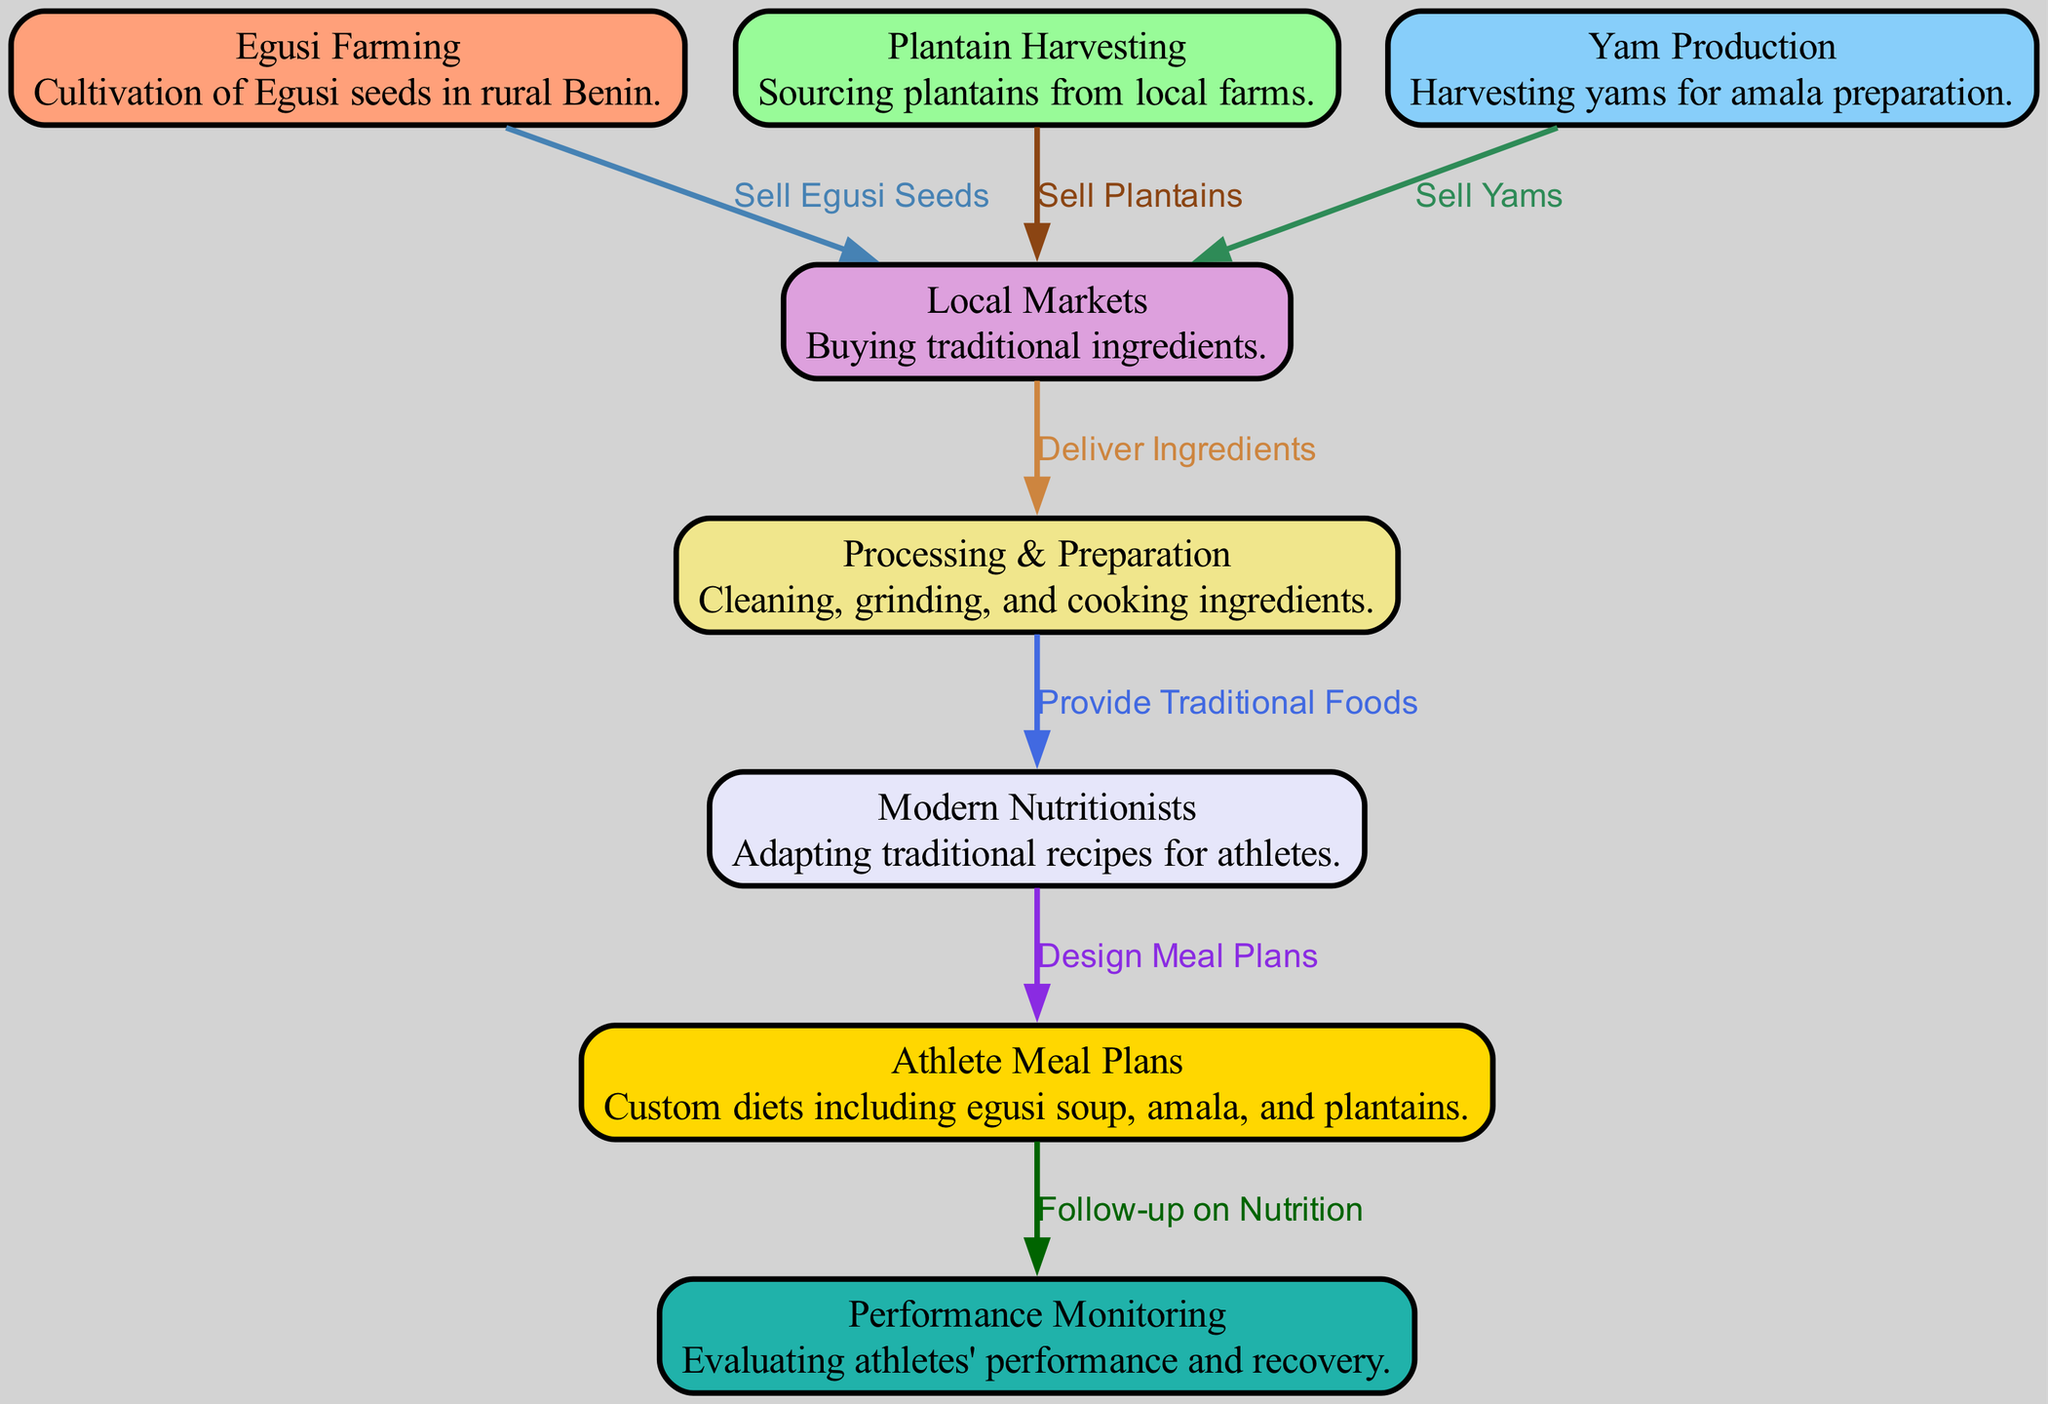What is the first node in the diagram? The first node is "Egusi Farming," which represents the cultivation of Egusi seeds. This can be determined by looking at the order of the nodes listed in the diagram.
Answer: Egusi Farming How many nodes are there in the food chain? By counting the individual nodes listed in the data, we find that there are a total of 8 nodes. This is a simple count of the items in the "nodes" section of the data.
Answer: 8 What is the final stage in the food chain? The final stage is "Performance Monitoring". This is the last node listed in the flow of the diagram, following "Athlete Meal Plans."
Answer: Performance Monitoring Which ingredient is associated with the node "Yam Production"? The ingredient associated with "Yam Production" is "Yams." This can be deduced from the description provided for that node.
Answer: Yams What is the relationship between "Processing & Preparation" and "Design Meal Plans"? The relationship is that "Processing & Preparation" provides traditional foods to "Modern Nutritionists," who then design meal plans. This is indicated by the directed flow of the edges in the diagram.
Answer: Provide Traditional Foods What do "Modern Nutritionists" adapt traditional foods for? "Modern Nutritionists" adapt traditional foods for "Athlete Meal Plans." This is shown by the edge that connects these two nodes.
Answer: Athlete Meal Plans How do athletes’ performance and nutrition connect in the diagram? Athletes' performance and nutrition connect through "Follow-up on Nutrition" which is linked to "Athlete Meal Plans." This indicates that the meal plans are monitored for athletes' performance.
Answer: Follow-up on Nutrition What action links "Local Markets" to "Processing & Preparation"? The action linking "Local Markets" to "Processing & Preparation" is "Deliver Ingredients." This connection indicates the flow of ingredients after purchasing them at local markets.
Answer: Deliver Ingredients How are "Egusi seeds," "Plantains," and "Yams" all related in the food chain? They are all sourced from farms and sold in "Local Markets," which then leads to "Processing & Preparation." This shows a common pathway in the food chain for these ingredients.
Answer: Sell Egusi Seeds, Sell Plantains, Sell Yams 